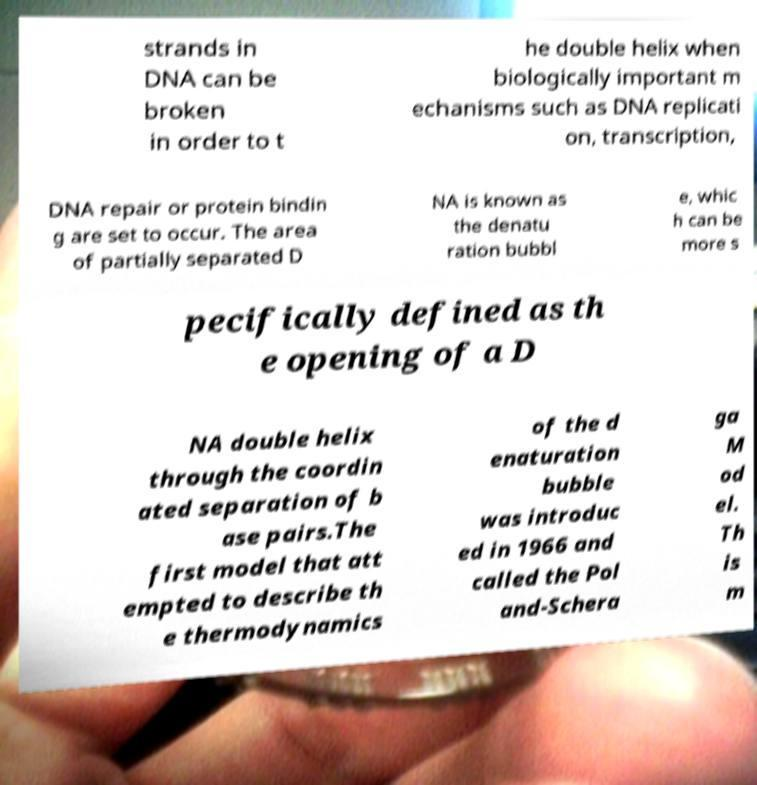Please read and relay the text visible in this image. What does it say? strands in DNA can be broken in order to t he double helix when biologically important m echanisms such as DNA replicati on, transcription, DNA repair or protein bindin g are set to occur. The area of partially separated D NA is known as the denatu ration bubbl e, whic h can be more s pecifically defined as th e opening of a D NA double helix through the coordin ated separation of b ase pairs.The first model that att empted to describe th e thermodynamics of the d enaturation bubble was introduc ed in 1966 and called the Pol and-Schera ga M od el. Th is m 